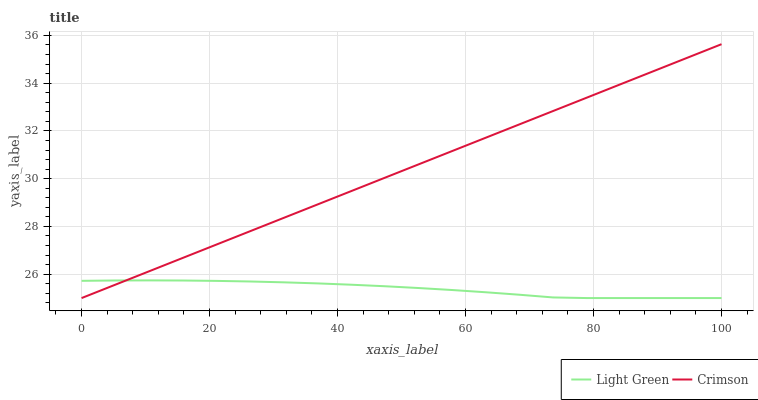Does Light Green have the maximum area under the curve?
Answer yes or no. No. Is Light Green the smoothest?
Answer yes or no. No. Does Light Green have the highest value?
Answer yes or no. No. 